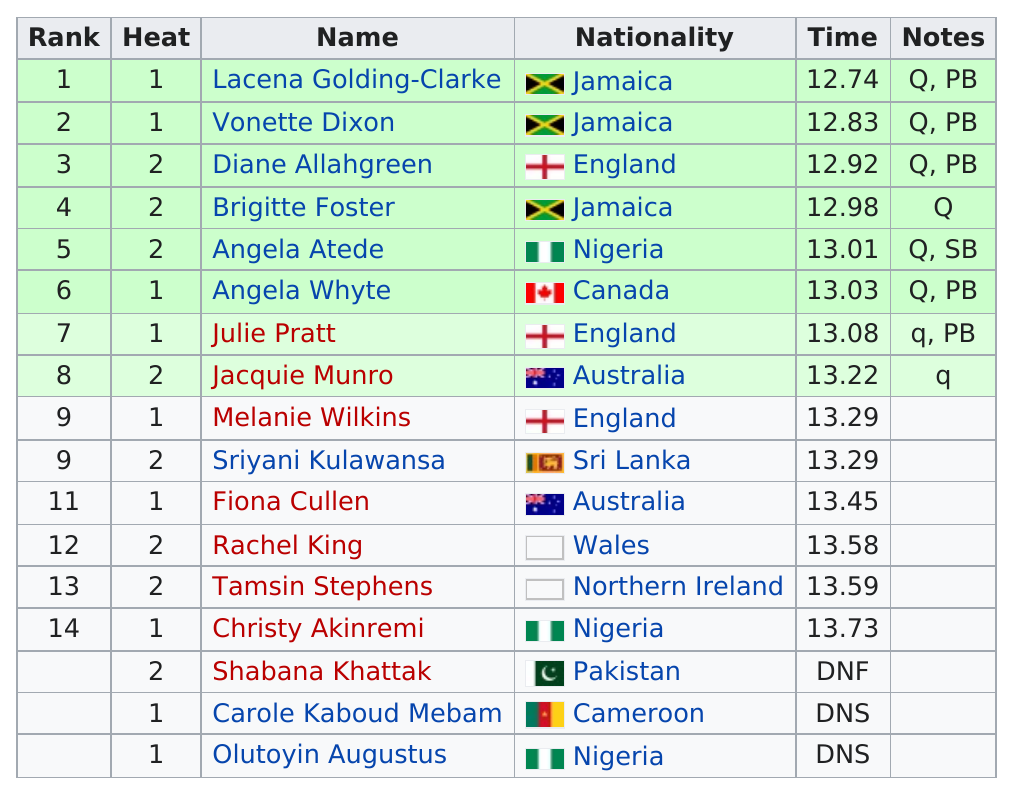Highlight a few significant elements in this photo. Lacena Golding-Clarke is the individual who achieved the first-rank position in the first heat. Four women completed the women's heat of the 100m hurdles in a time of less than 13 seconds. There are a total of 3 Jamaican athletes featured in the results. Tamsin Stephens finished directly before Akinremi. Lauren Golding-Clarke is the top-ranking athlete. 